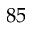Convert formula to latex. <formula><loc_0><loc_0><loc_500><loc_500>8 5</formula> 